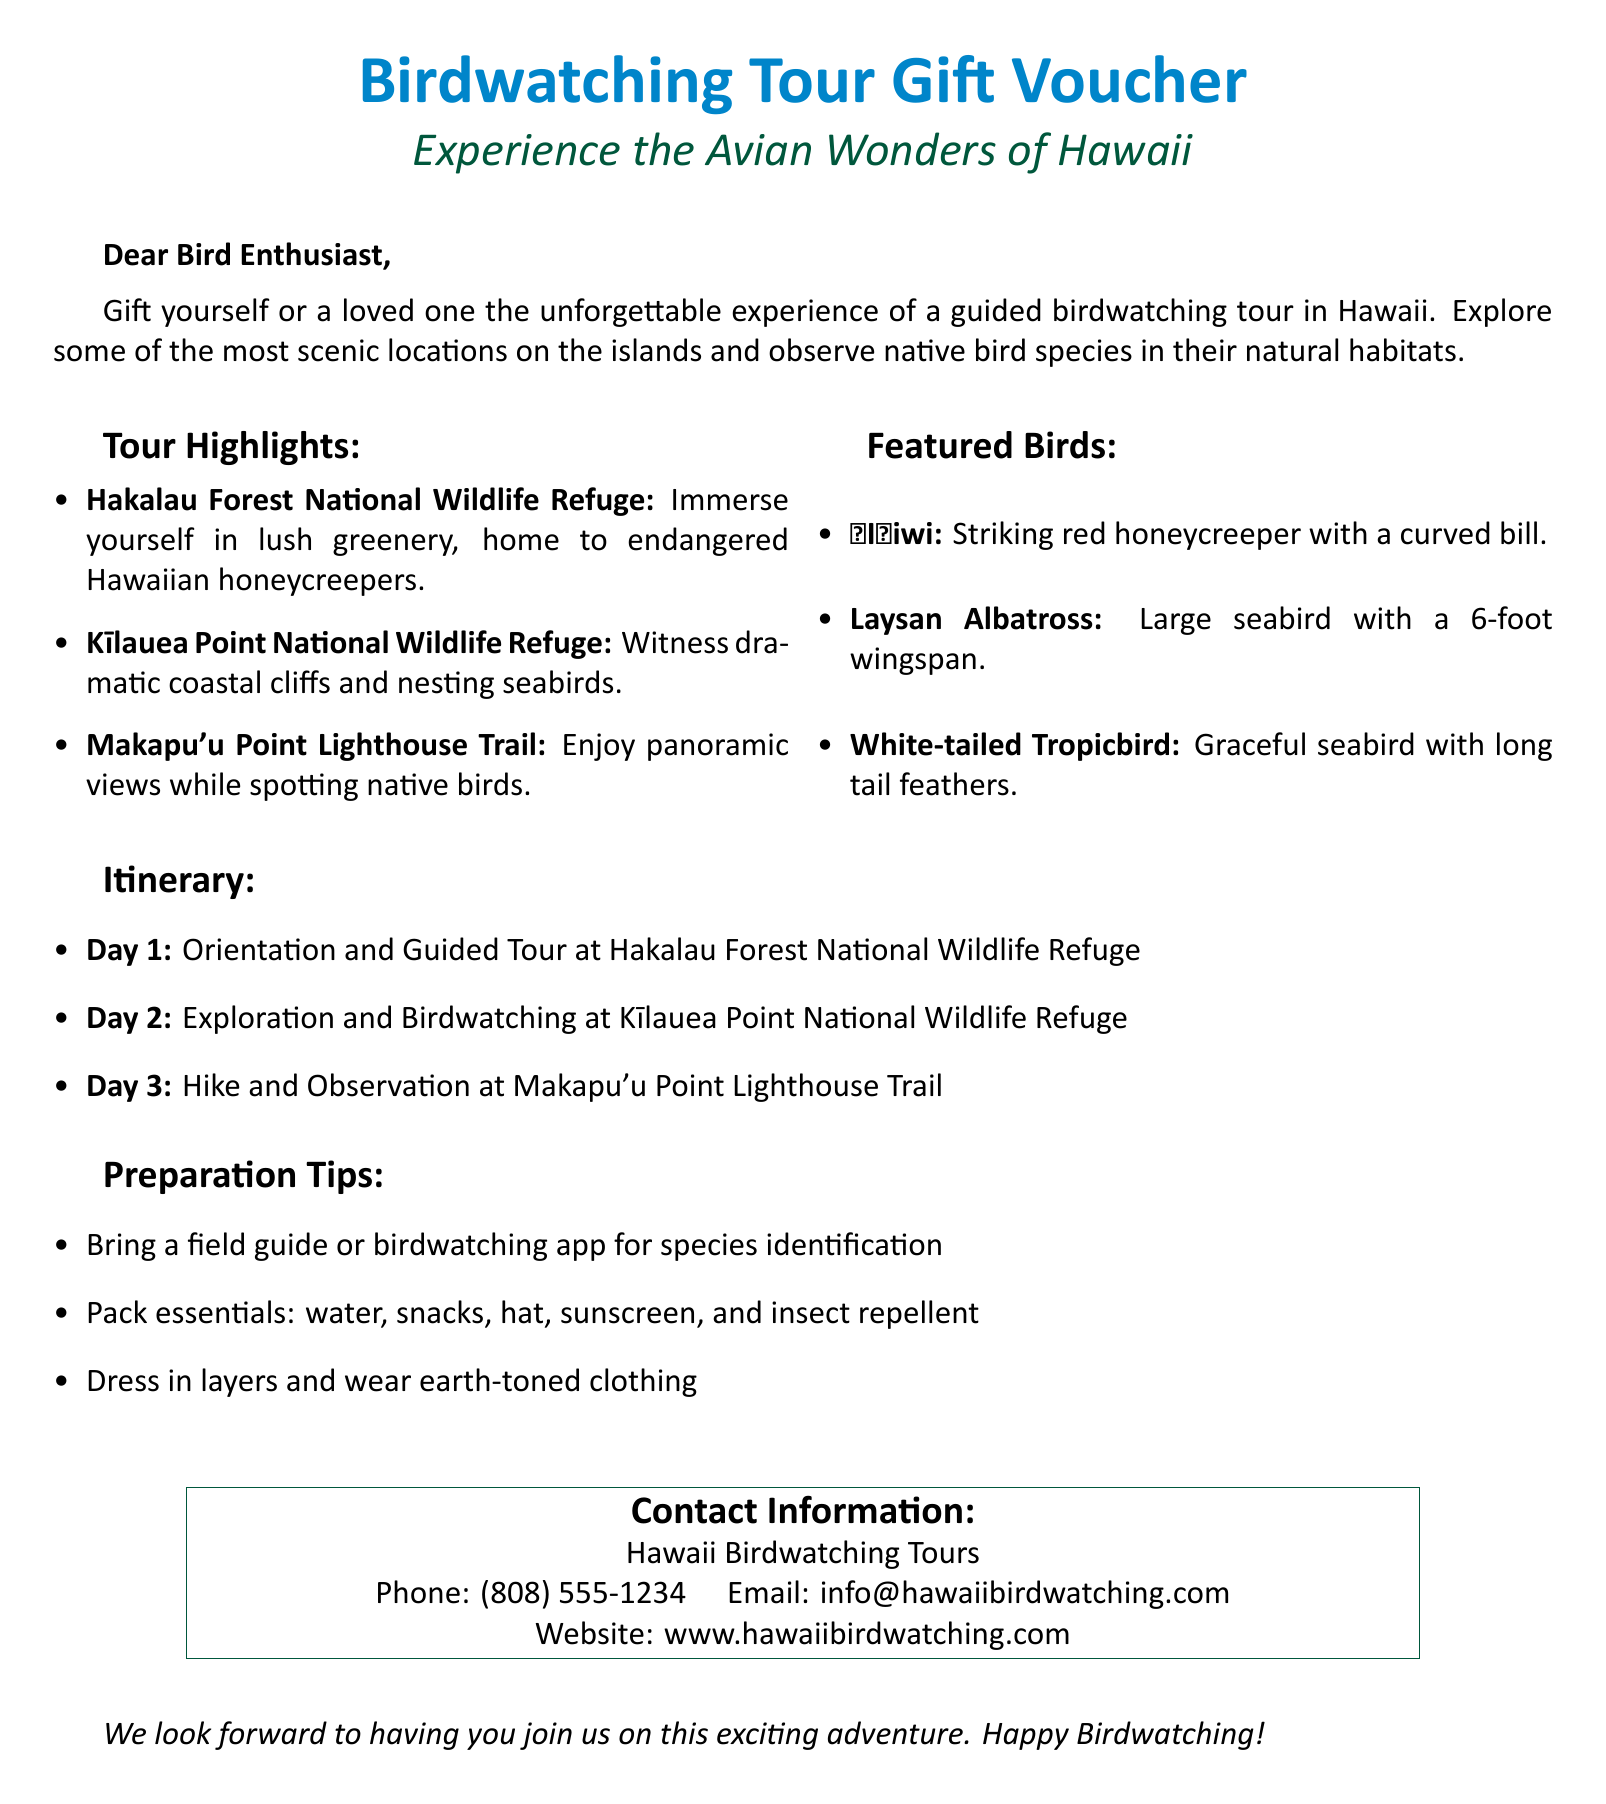What is the title of the voucher? The title of the voucher is prominently displayed at the top of the document.
Answer: Birdwatching Tour Gift Voucher What is the first featured bird mentioned? The first featured bird is listed under the "Featured Birds" section in the document.
Answer: ʻIʻiwi How many days is the itinerary for the birdwatching tour? The number of days is indicated in the "Itinerary" section of the document.
Answer: 3 What location is highlighted for Day 2 of the itinerary? Day 2 of the itinerary specifies a location where the tour will take place.
Answer: Kīlauea Point National Wildlife Refuge What should participants pack as essentials? Essential items to pack are listed in the "Preparation Tips" section of the document.
Answer: water, snacks, hat, sunscreen, and insect repellent Who is providing the birdwatching tour? The provider's name is mentioned at the bottom of the document under contact information.
Answer: Hawaii Birdwatching Tours What is the recommended attire for the tour? The document advises on clothing to wear for the birdwatching tour.
Answer: earth-toned clothing What is the contact phone number? The contact phone number is provided in the "Contact Information" section for inquiries.
Answer: (808) 555-1234 